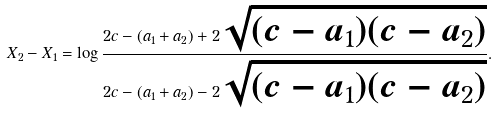<formula> <loc_0><loc_0><loc_500><loc_500>X _ { 2 } - X _ { 1 } = \log \frac { 2 c - ( a _ { 1 } + a _ { 2 } ) + 2 \sqrt { ( c - a _ { 1 } ) ( c - a _ { 2 } ) } } { 2 c - ( a _ { 1 } + a _ { 2 } ) - 2 \sqrt { ( c - a _ { 1 } ) ( c - a _ { 2 } ) } } .</formula> 